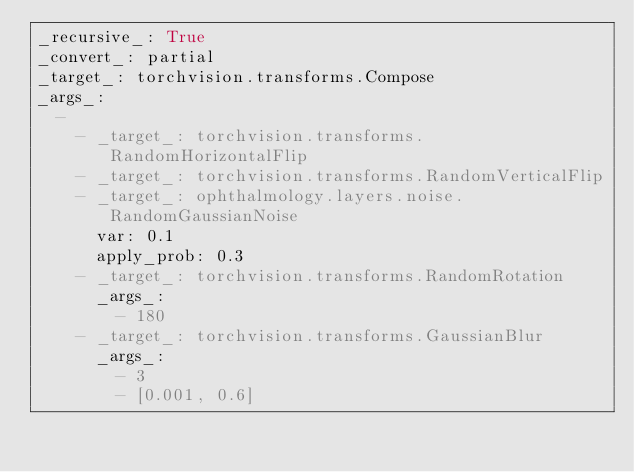<code> <loc_0><loc_0><loc_500><loc_500><_YAML_>_recursive_: True
_convert_: partial
_target_: torchvision.transforms.Compose
_args_:
  -
    - _target_: torchvision.transforms.RandomHorizontalFlip
    - _target_: torchvision.transforms.RandomVerticalFlip
    - _target_: ophthalmology.layers.noise.RandomGaussianNoise
      var: 0.1
      apply_prob: 0.3
    - _target_: torchvision.transforms.RandomRotation
      _args_:
        - 180
    - _target_: torchvision.transforms.GaussianBlur
      _args_:
        - 3
        - [0.001, 0.6]
</code> 